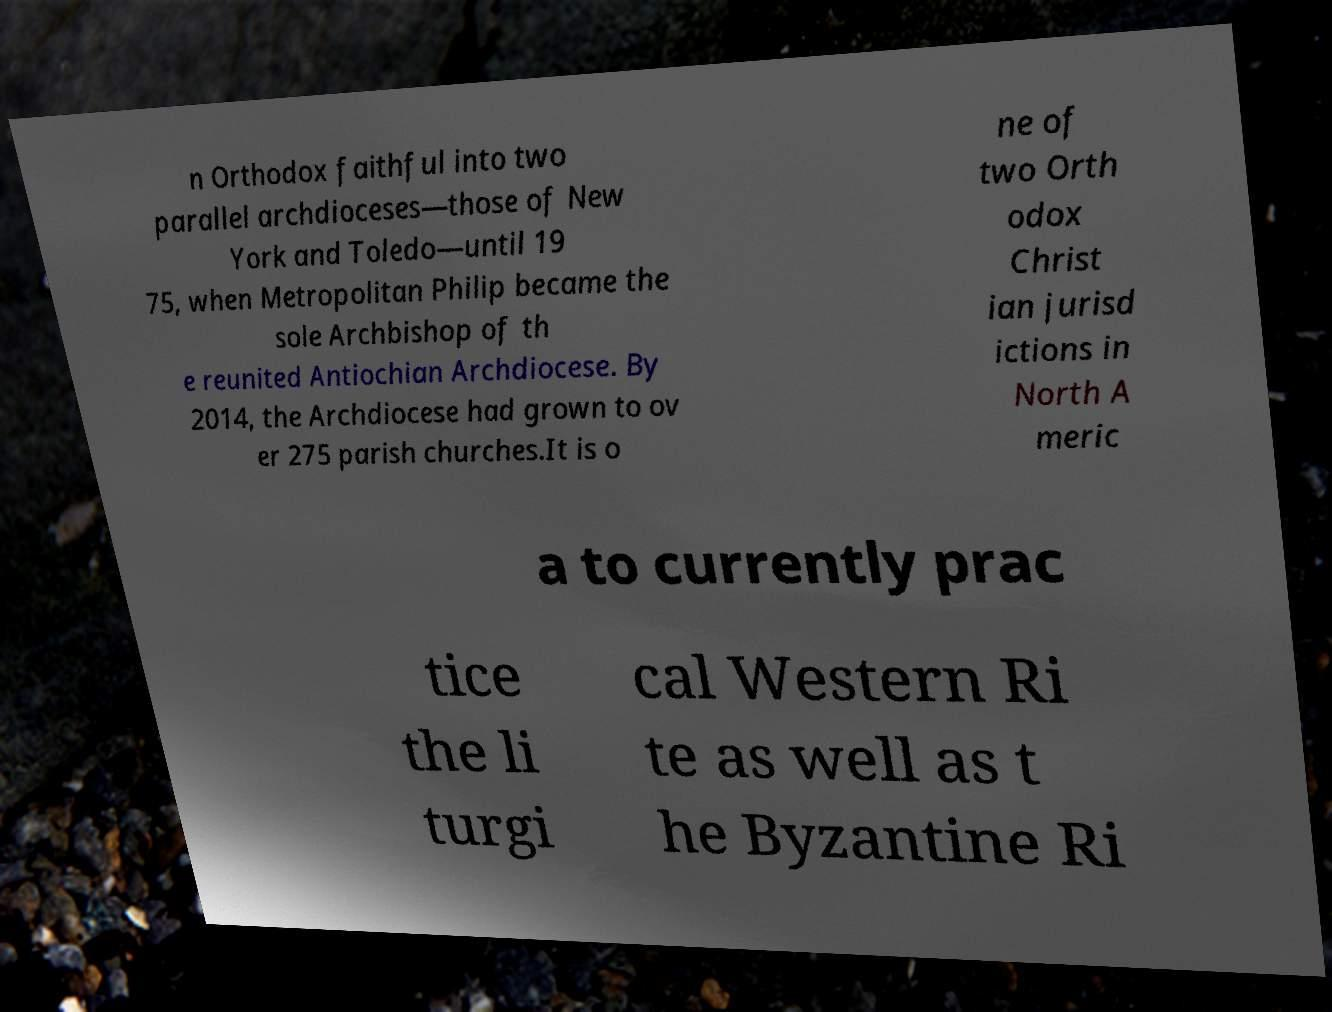What messages or text are displayed in this image? I need them in a readable, typed format. n Orthodox faithful into two parallel archdioceses—those of New York and Toledo—until 19 75, when Metropolitan Philip became the sole Archbishop of th e reunited Antiochian Archdiocese. By 2014, the Archdiocese had grown to ov er 275 parish churches.It is o ne of two Orth odox Christ ian jurisd ictions in North A meric a to currently prac tice the li turgi cal Western Ri te as well as t he Byzantine Ri 